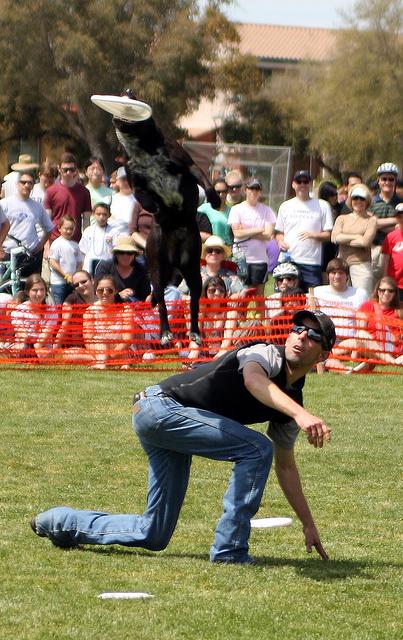Is the man wearing a hat?
Quick response, please. Yes. What is in the dog's mouth?
Write a very short answer. Frisbee. Is the man wearing sunglasses?
Quick response, please. Yes. 